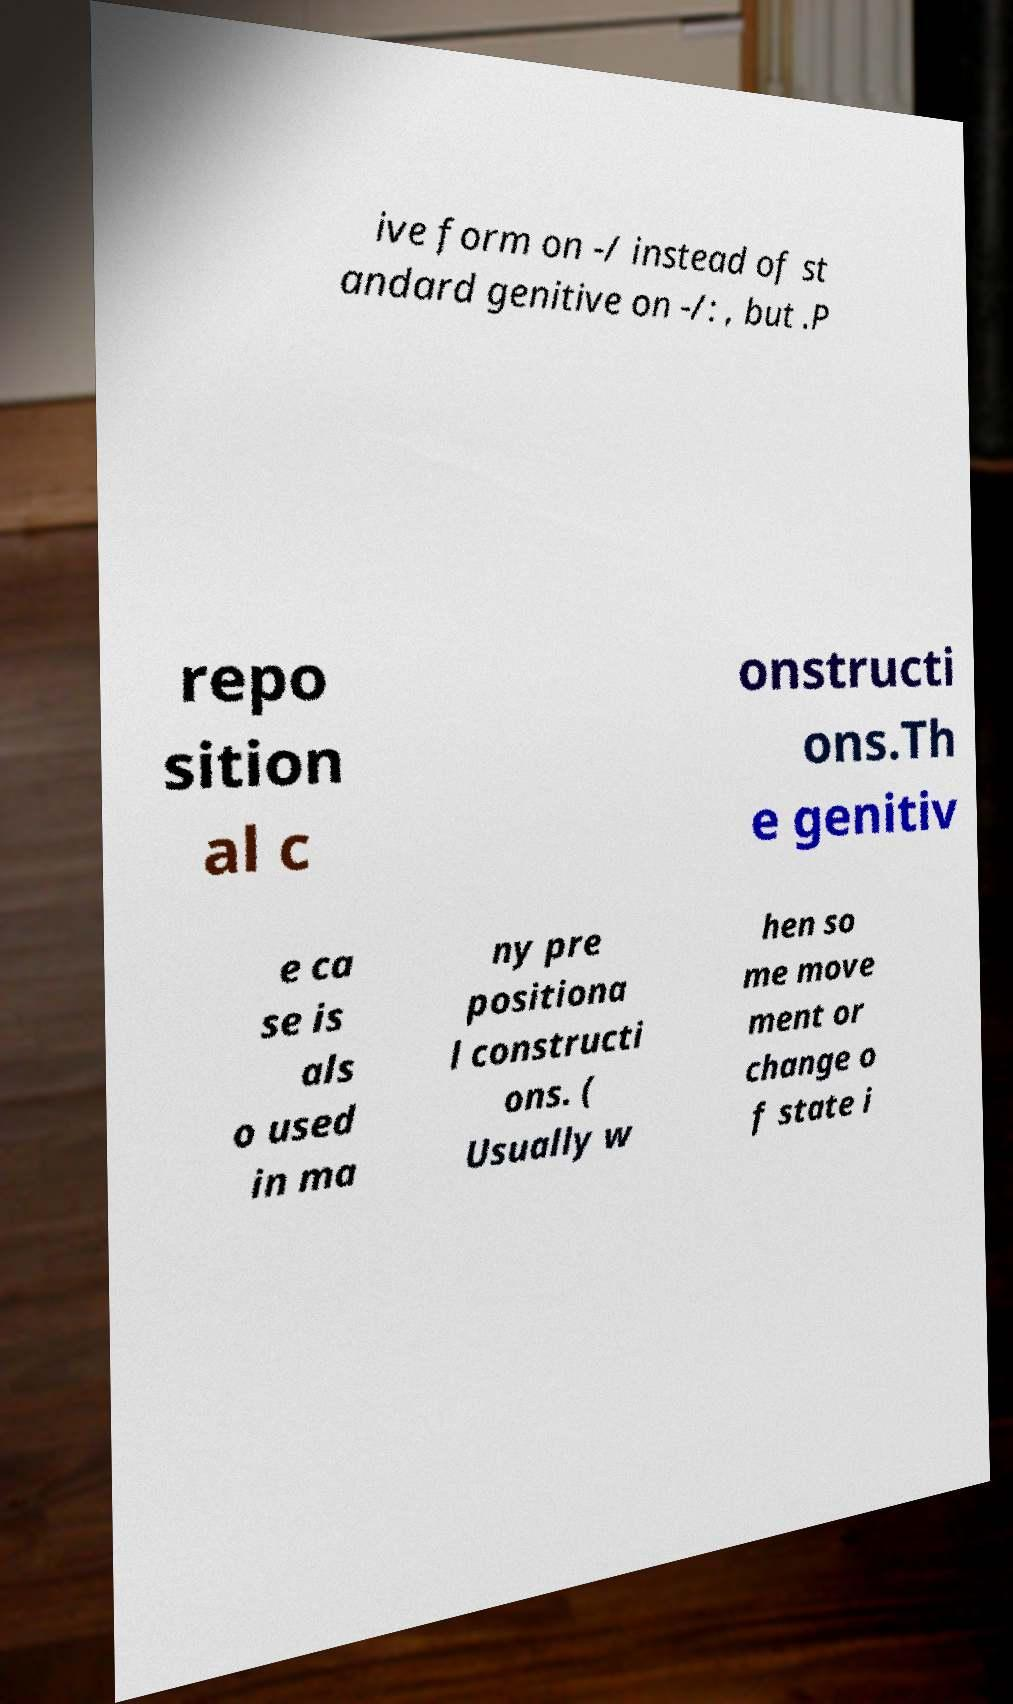For documentation purposes, I need the text within this image transcribed. Could you provide that? ive form on -/ instead of st andard genitive on -/: , but .P repo sition al c onstructi ons.Th e genitiv e ca se is als o used in ma ny pre positiona l constructi ons. ( Usually w hen so me move ment or change o f state i 